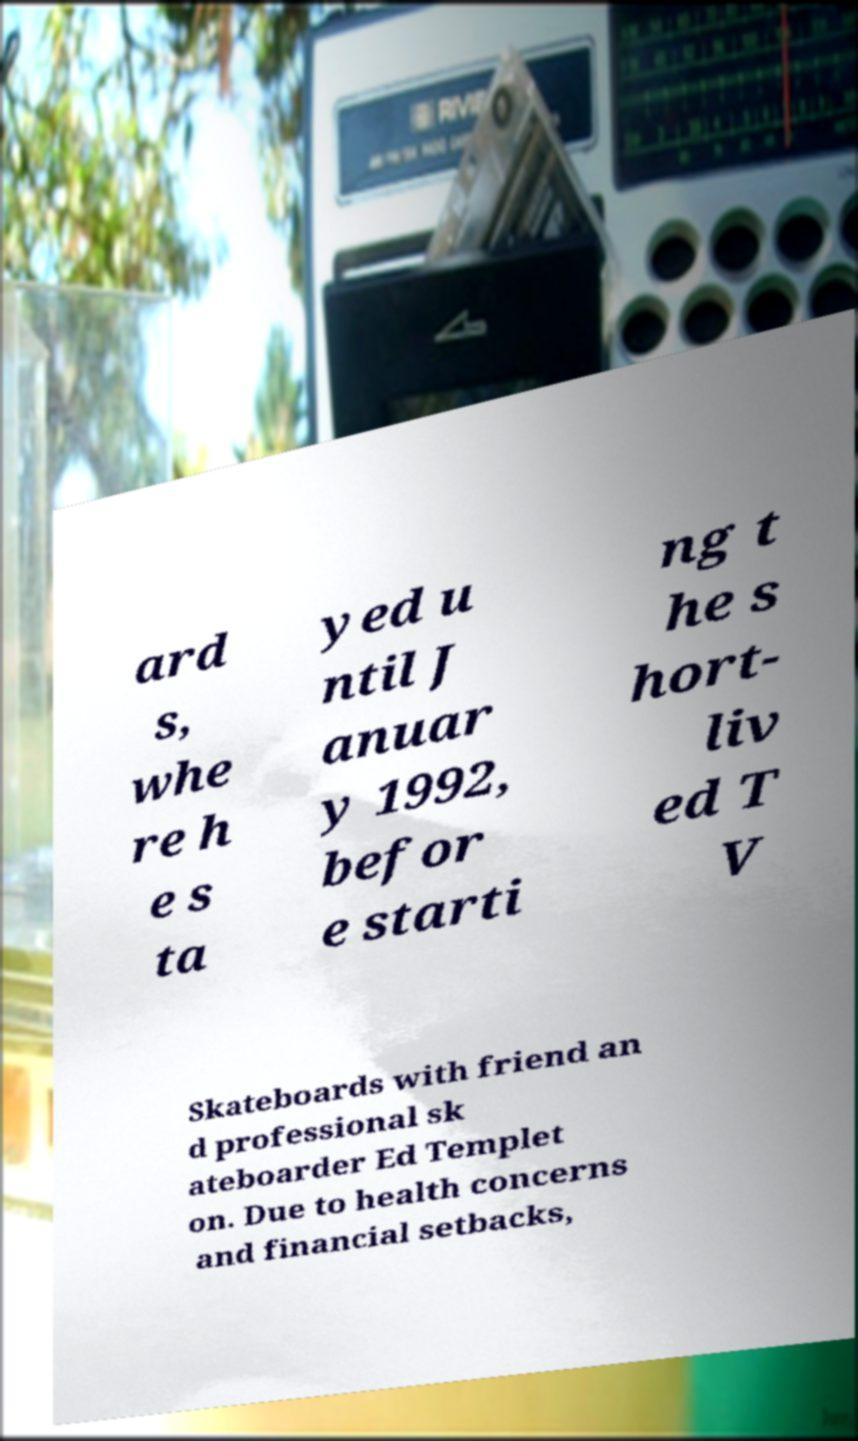Please identify and transcribe the text found in this image. ard s, whe re h e s ta yed u ntil J anuar y 1992, befor e starti ng t he s hort- liv ed T V Skateboards with friend an d professional sk ateboarder Ed Templet on. Due to health concerns and financial setbacks, 